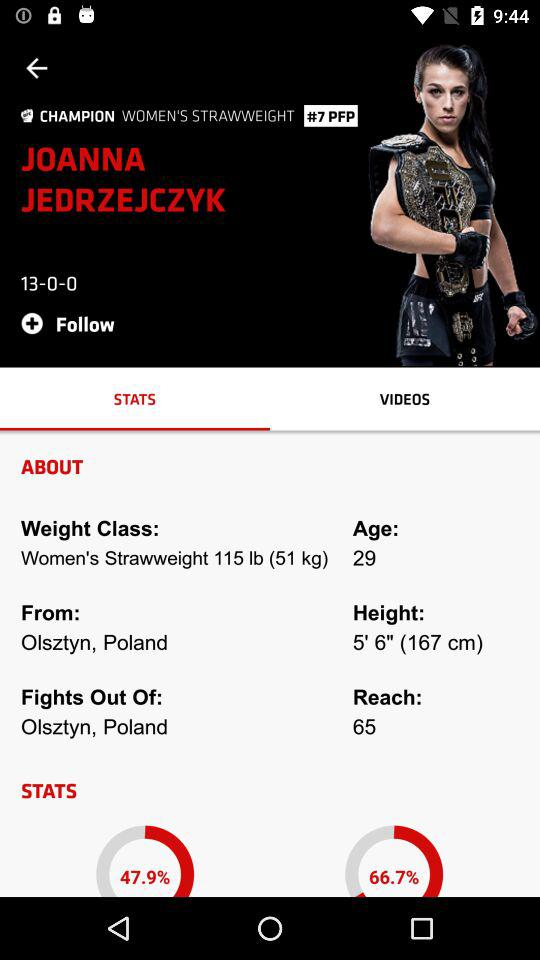Where is Joanna Jedrzejczyk from? Joanna Jedrzejczyk is from Olsztyn, Poland. 